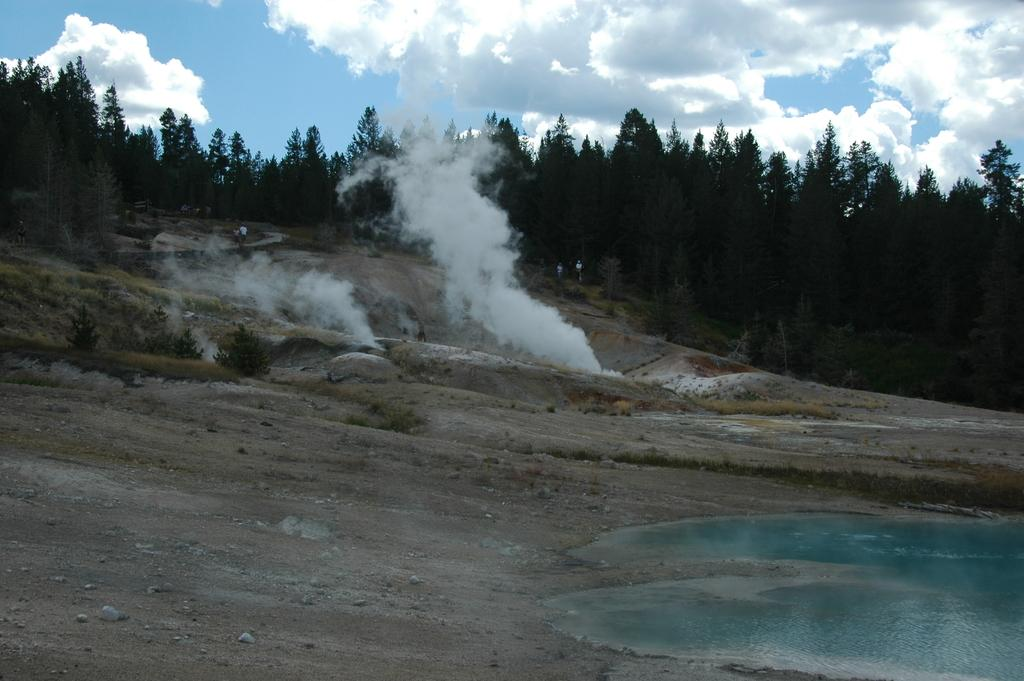What is one of the natural elements present in the image? There is water in the image. What can be seen rising from the ground in the image? There is smoke in the image. What type of vegetation is visible in the image? There is grass in the image. What part of the natural environment is visible in the image? The ground is visible in the image. What type of trees can be seen in the image? There are trees in the image. What is visible in the sky in the image? The sky is visible in the image, and clouds are present. What type of seat can be seen in the image? There is no seat present in the image. What reward is being given to the trees in the image? There is no reward being given to the trees in the image; they are simply standing in their natural environment. 